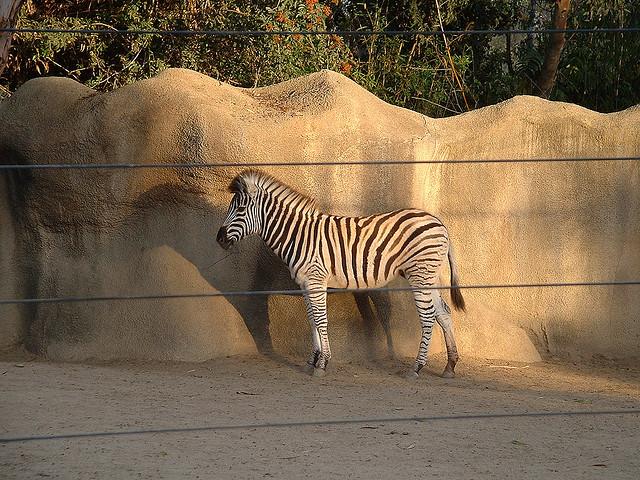What color are the flowers?
Give a very brief answer. Red. What animal is this?
Concise answer only. Zebra. What are the lines going across the front of the picture?
Short answer required. Fence. 